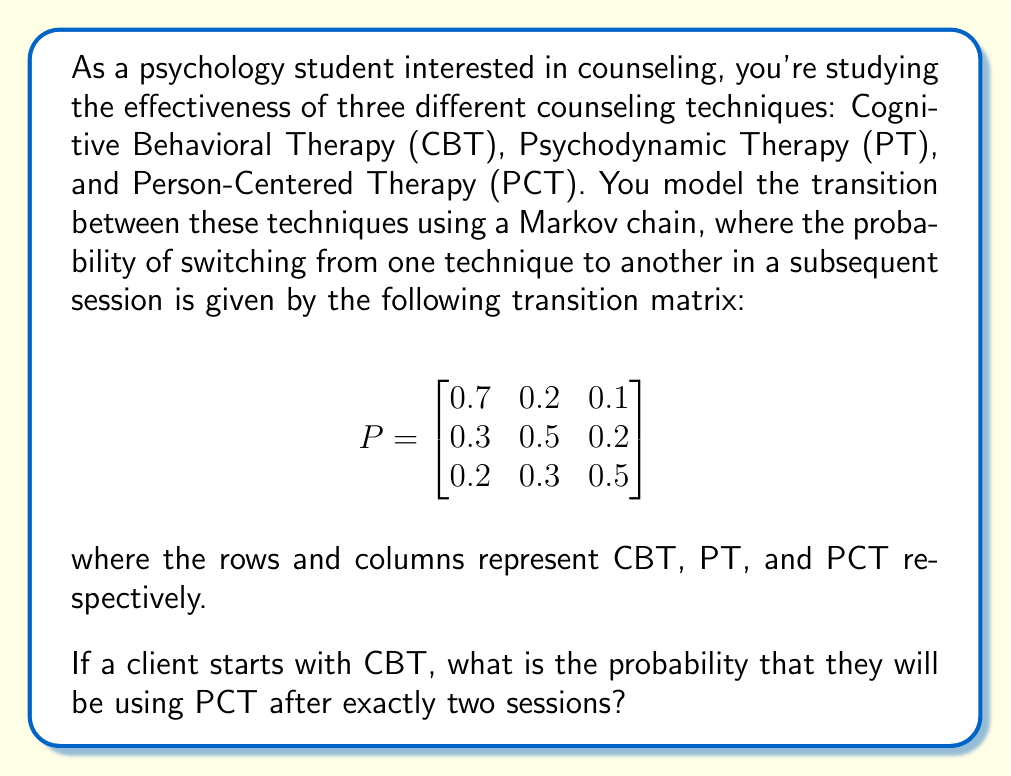Teach me how to tackle this problem. To solve this problem, we need to use the properties of Markov chains and matrix multiplication. Let's break it down step-by-step:

1) The given transition matrix $P$ represents the probability of moving from one state to another in a single step (or session in this case).

2) To find the probability of being in a certain state after two steps, we need to multiply the transition matrix by itself: $P^2$.

3) Let's calculate $P^2$:

   $$P^2 = \begin{bmatrix}
   0.7 & 0.2 & 0.1 \\
   0.3 & 0.5 & 0.2 \\
   0.2 & 0.3 & 0.5
   \end{bmatrix} \times \begin{bmatrix}
   0.7 & 0.2 & 0.1 \\
   0.3 & 0.5 & 0.2 \\
   0.2 & 0.3 & 0.5
   \end{bmatrix}$$

4) Performing the matrix multiplication:

   $$P^2 = \begin{bmatrix}
   (0.7 \times 0.7 + 0.2 \times 0.3 + 0.1 \times 0.2) & (0.7 \times 0.2 + 0.2 \times 0.5 + 0.1 \times 0.3) & (0.7 \times 0.1 + 0.2 \times 0.2 + 0.1 \times 0.5) \\
   (0.3 \times 0.7 + 0.5 \times 0.3 + 0.2 \times 0.2) & (0.3 \times 0.2 + 0.5 \times 0.5 + 0.2 \times 0.3) & (0.3 \times 0.1 + 0.5 \times 0.2 + 0.2 \times 0.5) \\
   (0.2 \times 0.7 + 0.3 \times 0.3 + 0.5 \times 0.2) & (0.2 \times 0.2 + 0.3 \times 0.5 + 0.5 \times 0.3) & (0.2 \times 0.1 + 0.3 \times 0.2 + 0.5 \times 0.5)
   \end{bmatrix}$$

5) Calculating each element:

   $$P^2 = \begin{bmatrix}
   0.55 & 0.29 & 0.16 \\
   0.37 & 0.41 & 0.22 \\
   0.29 & 0.37 & 0.34
   \end{bmatrix}$$

6) The client starts with CBT, which corresponds to the first row of the matrix. We're interested in the probability of ending up with PCT after two sessions, which is the third column.

7) Therefore, the probability we're looking for is the element in the first row, third column of $P^2$, which is 0.16.
Answer: 0.16 